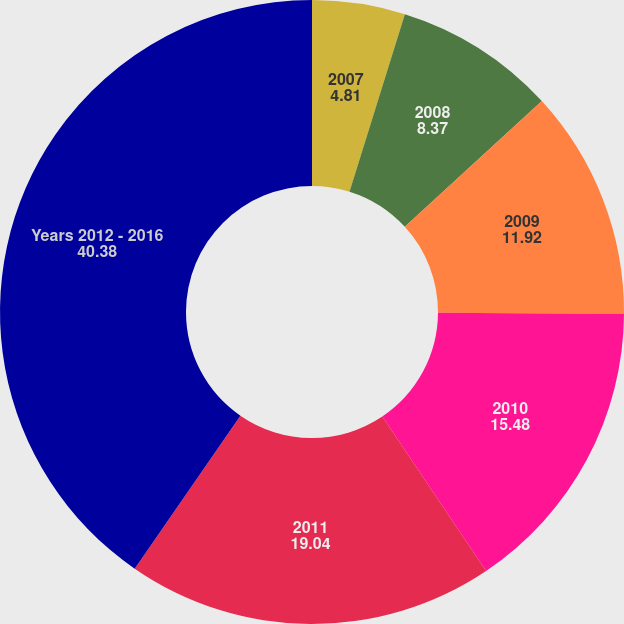Convert chart to OTSL. <chart><loc_0><loc_0><loc_500><loc_500><pie_chart><fcel>2007<fcel>2008<fcel>2009<fcel>2010<fcel>2011<fcel>Years 2012 - 2016<nl><fcel>4.81%<fcel>8.37%<fcel>11.92%<fcel>15.48%<fcel>19.04%<fcel>40.38%<nl></chart> 